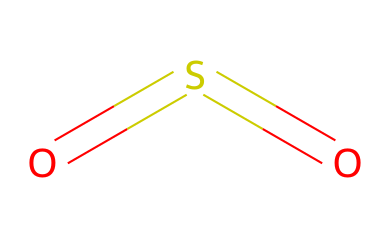What is the name of this chemical? The SMILES representation "O=S=O" corresponds to sulfur dioxide, which is a well-known gas, often emitted by volcanic activity.
Answer: sulfur dioxide How many sulfur atoms are present in this structure? The structure is represented as "O=S=O," indicating that there is one sulfur atom at the center bonded to two oxygen atoms. Thus, the count of sulfur atoms is one.
Answer: one How many double bonds does this molecule have? The SMILES "O=S=O" illustrates two double bonds between one sulfur atom and each of the two oxygen atoms. Therefore, the total number of double bonds in this molecule is two.
Answer: two Is sulfur dioxide a gas at room temperature? Given that sulfur dioxide (SO2) is classified as a gas under standard conditions, the answer is yes.
Answer: yes What type of bonds connects sulfur to oxygen in this molecule? The representation shows double bonds between sulfur and oxygen, which indicates that the connections are strong covalent bonds formed by shared pairs of electrons.
Answer: double bonds Is this compound considered a greenhouse gas? Sulfur dioxide does have a role in climate and air quality effects, but it is primarily categorized as an air pollutant rather than a significant greenhouse gas. Therefore, it can be considered not primarily a greenhouse gas.
Answer: no What does this chemical's structure suggest about its polarity? The bent shape due to the arrangement of the double bonds indicates that sulfur dioxide is polar, as it has a difference in electronegativity between sulfur and oxygen, leading to a dipole moment.
Answer: polar 